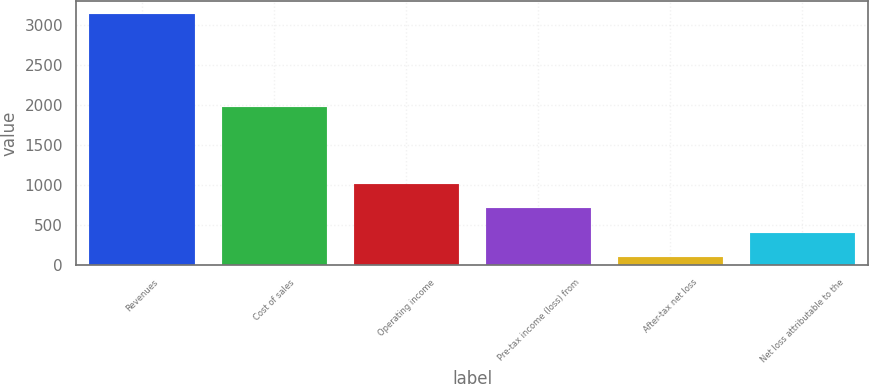Convert chart to OTSL. <chart><loc_0><loc_0><loc_500><loc_500><bar_chart><fcel>Revenues<fcel>Cost of sales<fcel>Operating income<fcel>Pre-tax income (loss) from<fcel>After-tax net loss<fcel>Net loss attributable to the<nl><fcel>3140<fcel>1973<fcel>1009.2<fcel>704.8<fcel>96<fcel>400.4<nl></chart> 